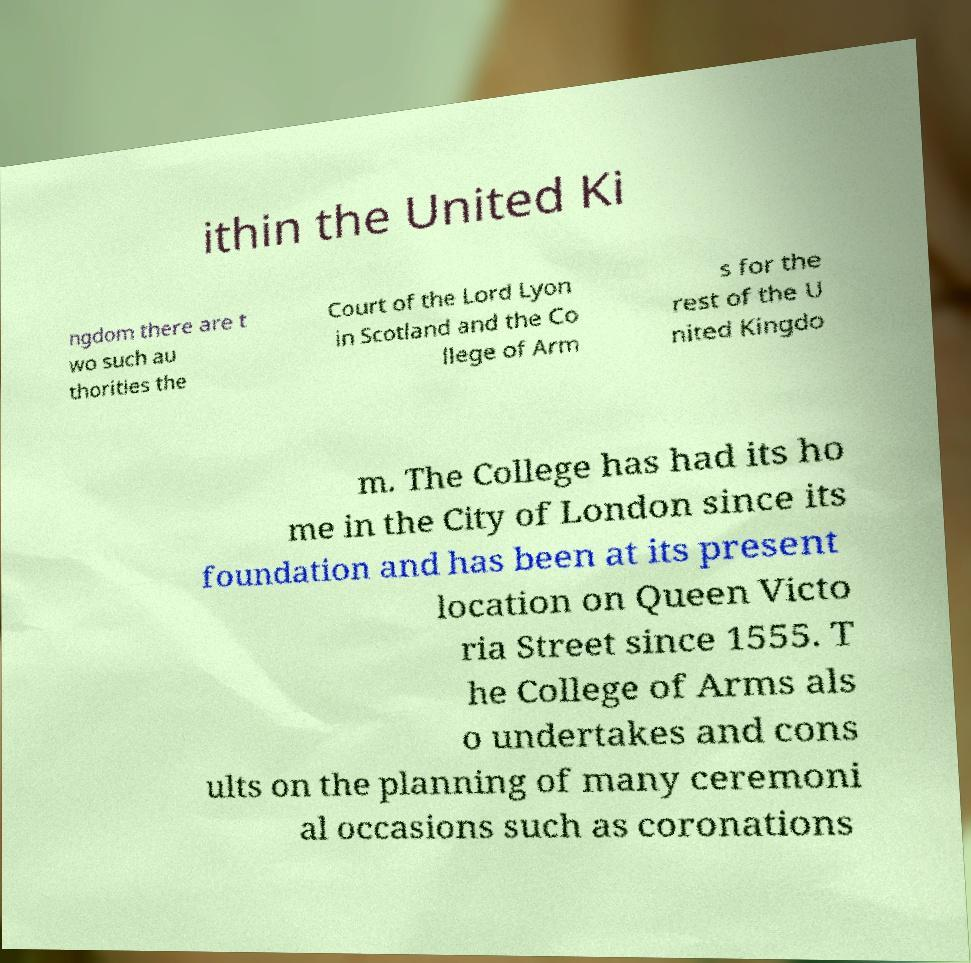Please read and relay the text visible in this image. What does it say? ithin the United Ki ngdom there are t wo such au thorities the Court of the Lord Lyon in Scotland and the Co llege of Arm s for the rest of the U nited Kingdo m. The College has had its ho me in the City of London since its foundation and has been at its present location on Queen Victo ria Street since 1555. T he College of Arms als o undertakes and cons ults on the planning of many ceremoni al occasions such as coronations 